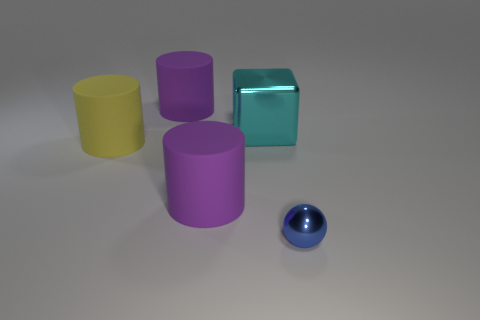Subtract all yellow cylinders. How many cylinders are left? 2 Subtract all purple matte cylinders. How many cylinders are left? 1 Add 3 small gray cubes. How many objects exist? 8 Subtract all cubes. How many objects are left? 4 Subtract 1 cylinders. How many cylinders are left? 2 Subtract 0 blue blocks. How many objects are left? 5 Subtract all brown cylinders. Subtract all yellow blocks. How many cylinders are left? 3 Subtract all brown balls. How many yellow cylinders are left? 1 Subtract all purple rubber cylinders. Subtract all matte objects. How many objects are left? 0 Add 2 balls. How many balls are left? 3 